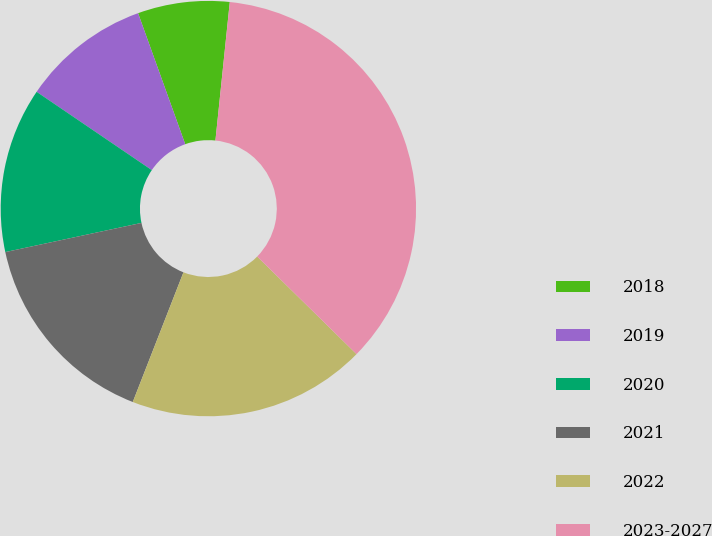<chart> <loc_0><loc_0><loc_500><loc_500><pie_chart><fcel>2018<fcel>2019<fcel>2020<fcel>2021<fcel>2022<fcel>2023-2027<nl><fcel>7.14%<fcel>10.0%<fcel>12.86%<fcel>15.71%<fcel>18.57%<fcel>35.71%<nl></chart> 